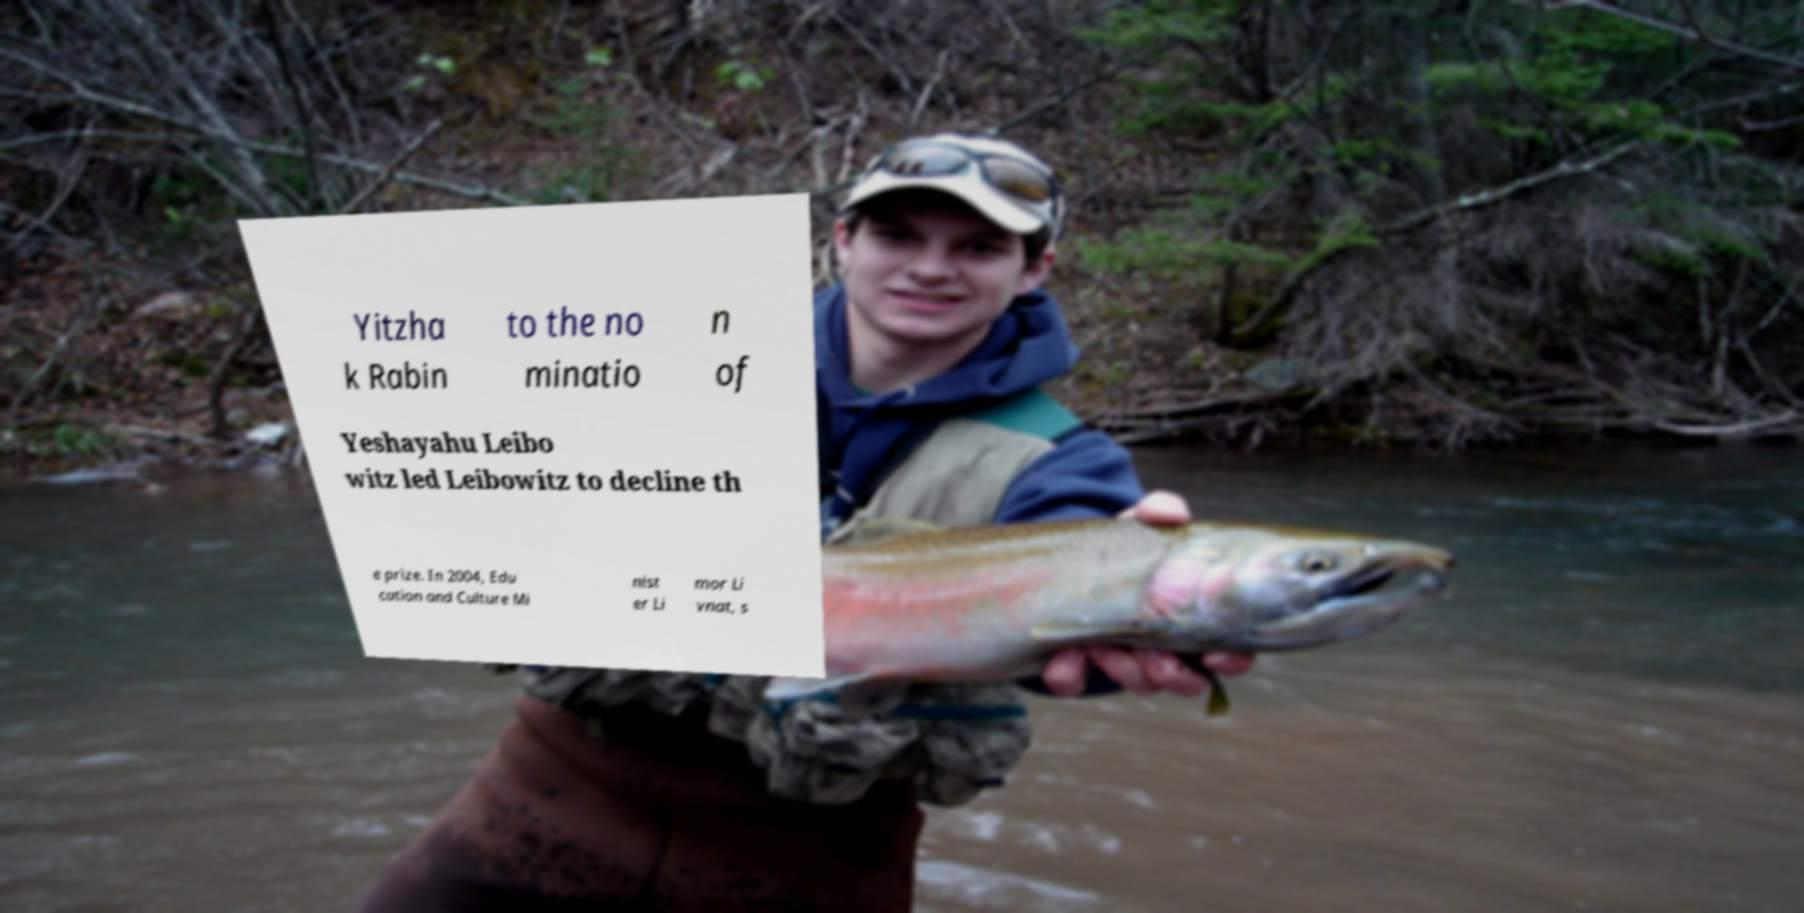I need the written content from this picture converted into text. Can you do that? Yitzha k Rabin to the no minatio n of Yeshayahu Leibo witz led Leibowitz to decline th e prize. In 2004, Edu cation and Culture Mi nist er Li mor Li vnat, s 